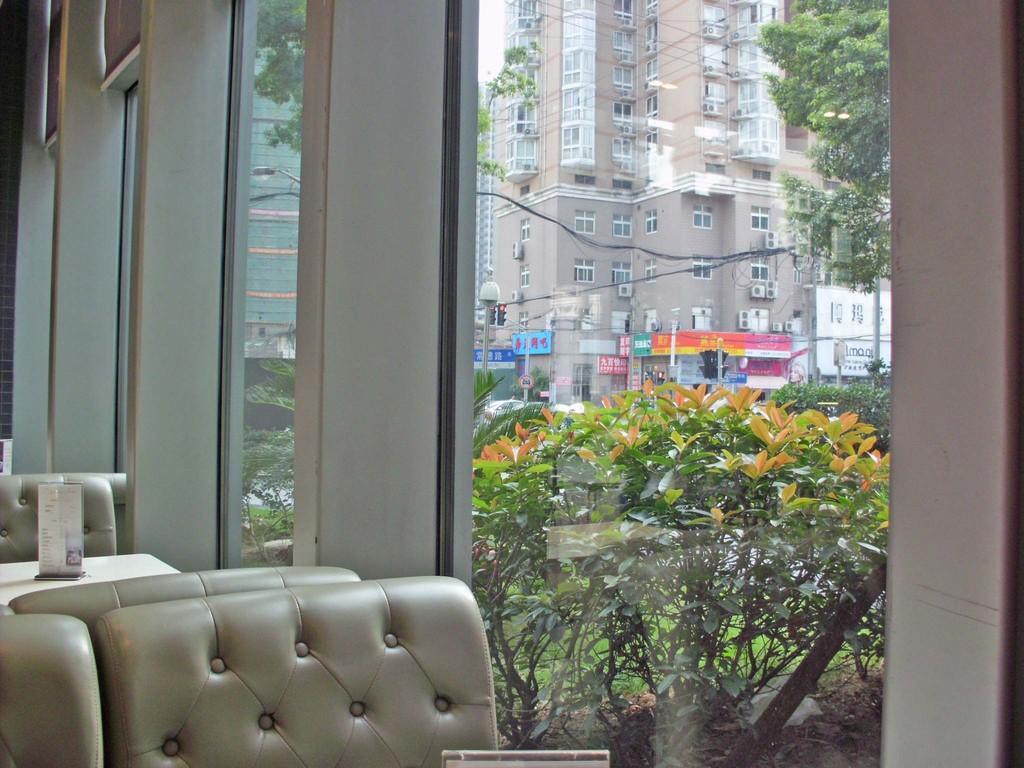Could you give a brief overview of what you see in this image? In this image, In the left side there is a sofa which is in white color, In the background there is a white color table on the table there is a white color board, In the middle there is a glass window and there are some plants which are in green color, There is a wall which is in white color. 